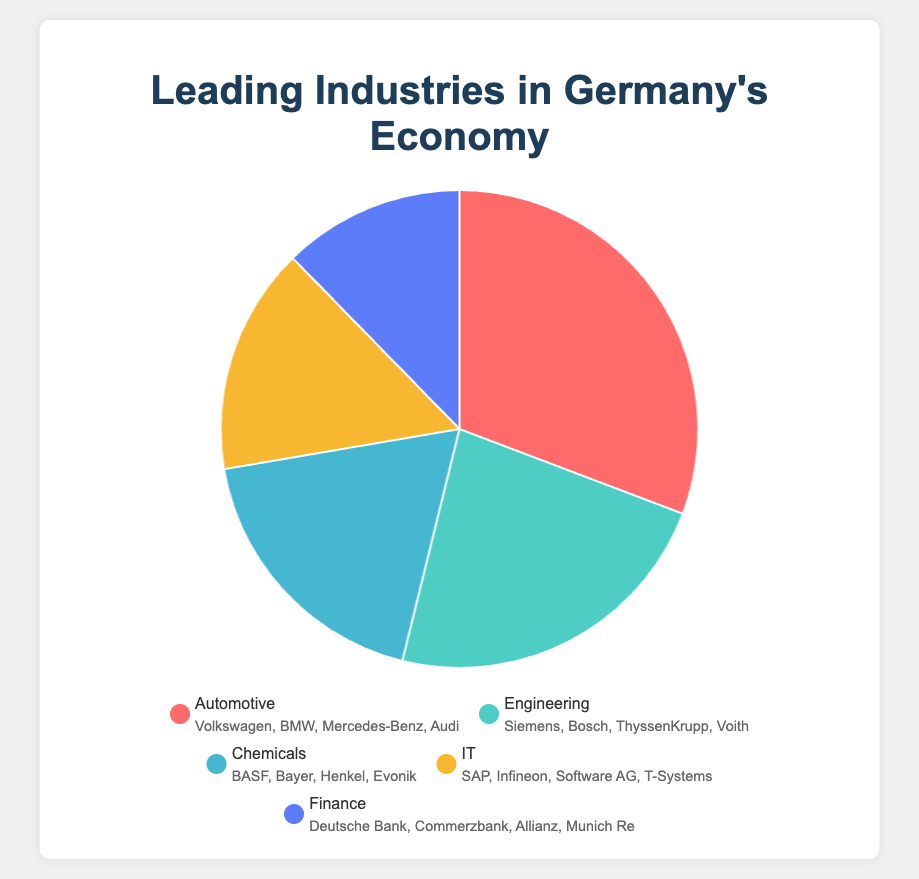What is the percentage of the Automotive and Engineering industries combined? To find the combined percentage, add the percentages of the Automotive (20%) and Engineering (15%) industries. Therefore, 20% + 15% = 35%.
Answer: 35% Which industry contributes the least to Germany's economy according to the pie chart? The industry with the smallest percentage is Finance, which accounts for 8% of the economy.
Answer: Finance How much larger is the Automotive industry compared to the IT industry? Subtract the IT industry's percentage (10%) from the Automotive industry's percentage (20%). So, 20% - 10% = 10%.
Answer: 10% Which two industries together account for more than one-third of Germany's economy? One-third of the economy is approximately 33.33%. Combining the Automotive (20%) and Engineering (15%) industries gives us 20% + 15% = 35%, which is more than one-third.
Answer: Automotive and Engineering Which industry has a percentage that is equal to the sum of the percentages of the IT and Finance industries? The IT industry is 10% and the Finance industry is 8%. Their sum is 10% + 8% = 18%. No single industry exactly matches 18%, but the closest is the Chemicals industry with 12%, which does not match the sum. Therefore, none match exactly.
Answer: None Rank the industries from highest to lowest percentage in Germany's economy. The industries sorted by percentage are: Automotive (20%), Engineering (15%), Chemicals (12%), IT (10%), Finance (8%).
Answer: Automotive, Engineering, Chemicals, IT, Finance What is the percentage difference between the Engineering and Chemicals industries? Calculate the difference by subtracting the Chemicals industry percentage (12%) from the Engineering industry percentage (15%). Therefore, 15% - 12% = 3%.
Answer: 3% 